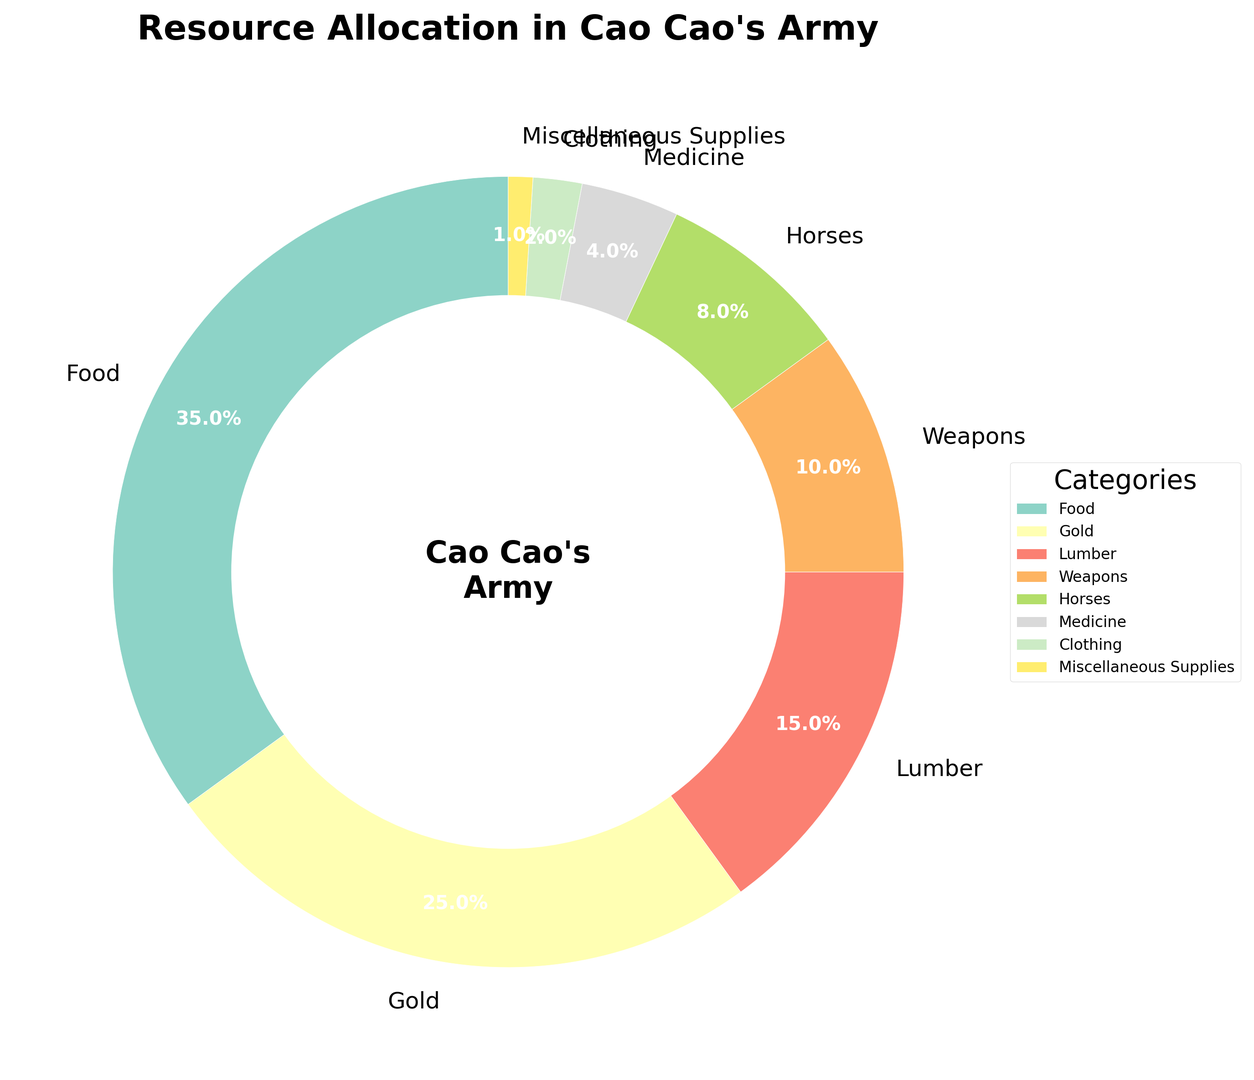What percentage of the resources goes to food and gold combined? To find the combined percentage for food and gold, sum the individual percentages of food (35%) and gold (25%). 35% + 25% = 60%
Answer: 60% Which category receives the least amount of resources? By looking at the percentages, the category with the smallest allocation is Miscellaneous Supplies, which is given 1% of the resources.
Answer: Miscellaneous Supplies Are there more resources allocated to weapons or horses? Comparing the percentages of weapons (10%) and horses (8%), more resources are allocated to weapons since 10% is greater than 8%.
Answer: Weapons What's the difference in resource allocation between clothing and medicine? Subtract the percentage allocated to clothing (2%) from the percentage allocated to medicine (4%). 4% - 2% = 2%
Answer: 2% How many categories have a resource allocation percentage greater than 10%? By examining the chart, the categories with percentages greater than 10% are food (35%) and gold (25%). There are 2 such categories.
Answer: 2 What is the visual appearance of the slice representing food in the pie chart? The food slice is the largest slice in the pie chart, representing 35% of the total allocation. It's likely positioned prominently given its size.
Answer: Largest slice Is the combined percentage of medicine and clothing more or less than the percentage allocated to horses? Sum the percentages of medicine (4%) and clothing (2%), which is 4% + 2% = 6%. The percentage for horses is 8%, so the combined percentage of medicine and clothing (6%) is less than that for horses (8%).
Answer: Less Which category, gold or lumber, has a higher allocation, and by how much? Gold is allocated 25% and lumber 15%. To find the difference, subtract the lumber percentage from the gold percentage: 25% - 15% = 10%. Gold has a higher allocation by 10%.
Answer: Gold, 10% What visual element is used to highlight the allocation to Cao Cao's army as a whole? A central circle with the label "Cao Cao's Army" is used in the middle of the pie chart to emphasize the central theme of the resource allocation.
Answer: Central circle with label 